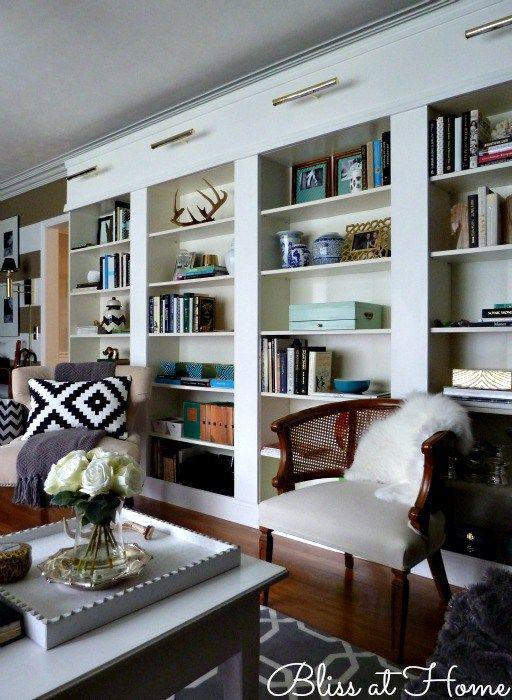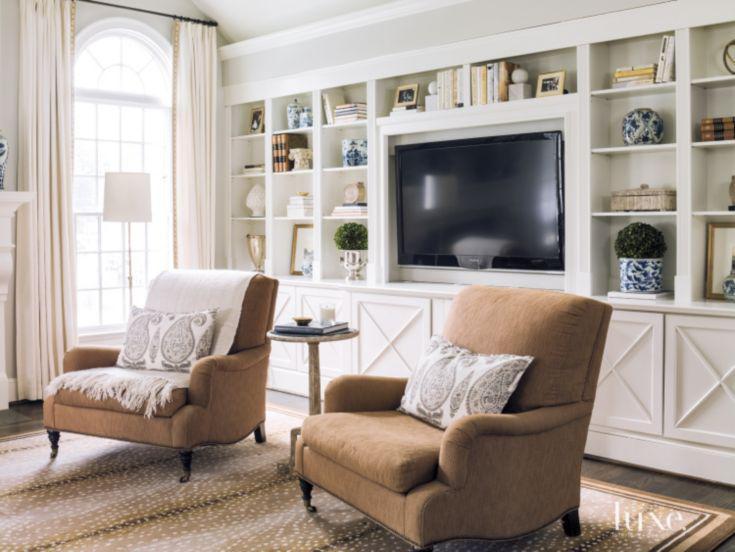The first image is the image on the left, the second image is the image on the right. Evaluate the accuracy of this statement regarding the images: "In one image, a large white shelving unit has solid panel doors at the bottom, open shelves at the top, and a television in the center position.". Is it true? Answer yes or no. Yes. 